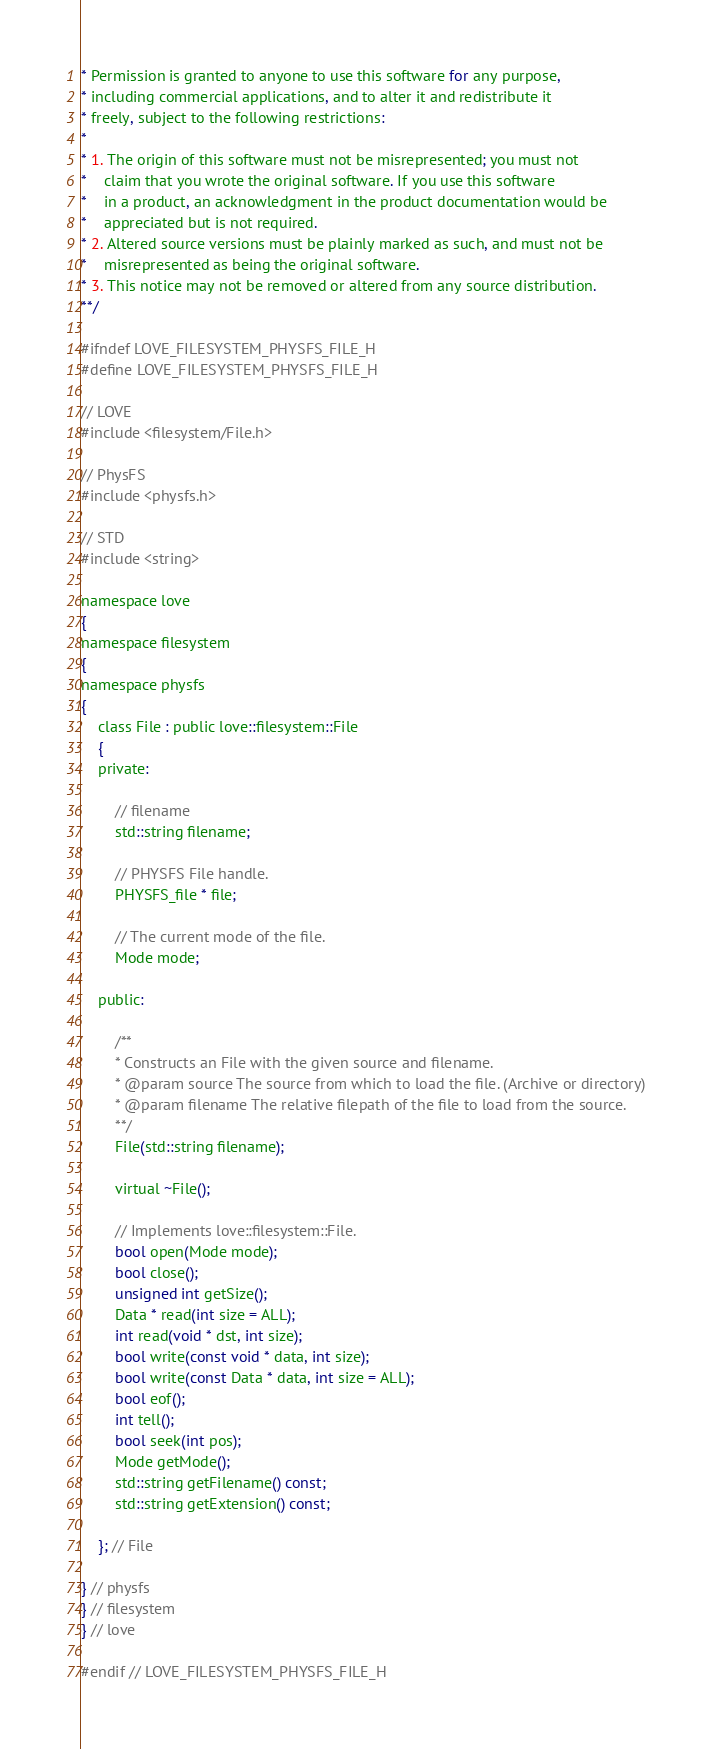<code> <loc_0><loc_0><loc_500><loc_500><_C_>* Permission is granted to anyone to use this software for any purpose,
* including commercial applications, and to alter it and redistribute it
* freely, subject to the following restrictions:
* 
* 1. The origin of this software must not be misrepresented; you must not
*    claim that you wrote the original software. If you use this software
*    in a product, an acknowledgment in the product documentation would be
*    appreciated but is not required.
* 2. Altered source versions must be plainly marked as such, and must not be
*    misrepresented as being the original software.
* 3. This notice may not be removed or altered from any source distribution.
**/

#ifndef LOVE_FILESYSTEM_PHYSFS_FILE_H
#define LOVE_FILESYSTEM_PHYSFS_FILE_H

// LOVE
#include <filesystem/File.h>

// PhysFS
#include <physfs.h>

// STD
#include <string>

namespace love
{
namespace filesystem
{
namespace physfs
{
	class File : public love::filesystem::File
	{
	private:

		// filename
		std::string filename;

		// PHYSFS File handle.
		PHYSFS_file * file;

		// The current mode of the file.
		Mode mode;

	public:

		/**
		* Constructs an File with the given source and filename.
		* @param source The source from which to load the file. (Archive or directory)
		* @param filename The relative filepath of the file to load from the source.
		**/
		File(std::string filename);

		virtual ~File();
		
		// Implements love::filesystem::File.
		bool open(Mode mode);
		bool close();
		unsigned int getSize();
		Data * read(int size = ALL);
		int read(void * dst, int size);
		bool write(const void * data, int size);
		bool write(const Data * data, int size = ALL);
		bool eof();
		int tell();
		bool seek(int pos);
		Mode getMode();
		std::string getFilename() const;
		std::string getExtension() const;

	}; // File

} // physfs
} // filesystem
} // love

#endif // LOVE_FILESYSTEM_PHYSFS_FILE_H
</code> 